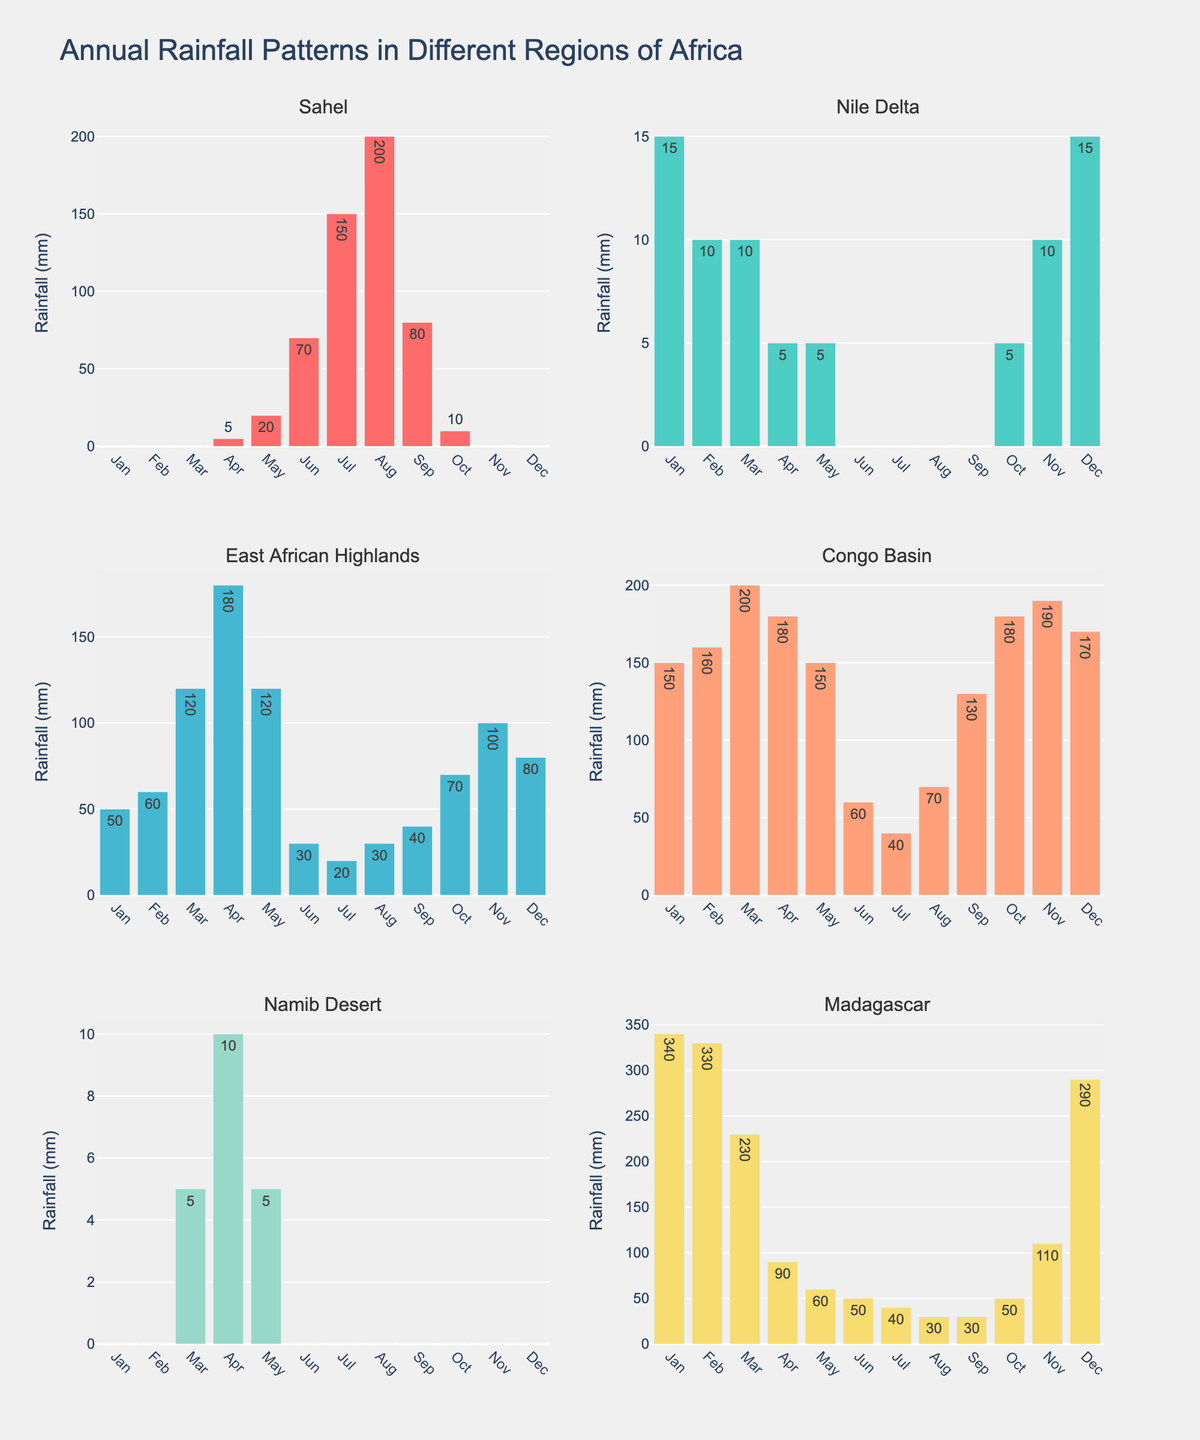What is the distribution of teaching methods for Math? The figure shows a pie chart for each subject. By looking at the Math pie chart, the distribution is: Direct Instruction (35%), Problem-Based Learning (25%), Collaborative Learning (20%), Flipped Classroom (15%), and Gamification (5%)
Answer: Direct Instruction (35%), Problem-Based Learning (25%), Collaborative Learning (20%), Flipped Classroom (15%), Gamification (5%) Which teaching method is most used in Science classrooms? By observing the Science pie chart, the largest section is for Inquiry-Based Learning, which covers 30% of the distribution
Answer: Inquiry-Based Learning (30%) How does the use of Direct Instruction compare between Math and English? By looking at both Math and English pie charts, Direct Instruction is 35% for Math and 15% for English. Direct Instruction is used more frequently in Math than in English
Answer: More in Math Which teaching method appears in both Art and History, and what are their respective percentages? From both Art and History pie charts, the common teaching method is 'Demonstration' in Art (20%) and 'Lecture' in History (15%)
Answer: Demonstration (20% Art), Lecture (15% History) What's the combined percentage for teaching methods that involve discussions (e.g., Collaborative Learning, Debate and Discussion)? From the pie charts: Collaborative Learning in Math (20%) and Debate and Discussion in History (25%). The combined percentage is 20% + 25% = 45%
Answer: 45% In which subject is the proportion of 'Direct Instruction' higher, Math or Science? By comparing the Direct Instruction in both subjects: Math has 35%, and Science has 15%. The proportion is higher in Math
Answer: Math How many teaching methods are listed for Music, and which method has the smallest percentage? The Music pie chart shows 4 teaching methods, and Ear Training with 25% is the smallest percentage
Answer: Four methods, Ear Training (25%) Which subject has the highest single percentage for any teaching method, and what is the method and percentage? By scanning all of the pie charts, Art has the highest single percentage with Studio-Based Learning at 40%
Answer: Art, Studio-Based Learning (40%) What's the total percentage for all 'Interactive' teaching methods across Science and History (assuming methods like Hands-On Experiments and Simulation and Role-Play are interactive)? From the pie charts: Hands-On Experiments in Science (25%) and Simulation and Role-Play in History (20%). The total percentage is 25% + 20% = 45%
Answer: 45% Considering the figures, which subject primarily uses performance (like Performance-Based Learning), and what is the percentage? Music uses Performance-Based Learning for 35%, which is clearly marked in the Music pie chart
Answer: Music, Performance-Based Learning (35%) 